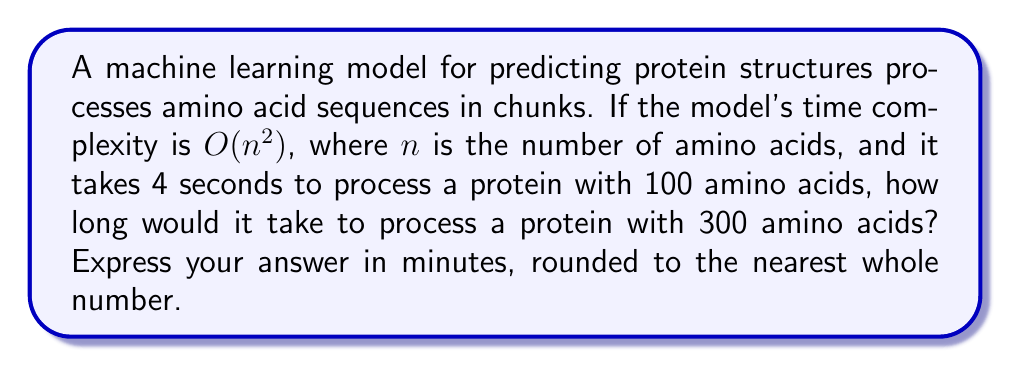Help me with this question. Let's approach this step-by-step:

1) The time complexity is $O(n^2)$, which means the processing time is proportional to the square of the input size.

2) We're given that for $n = 100$, the processing time $t = 4$ seconds.

3) Let's call the constant of proportionality $k$. So we can write:

   $t = kn^2$

4) For $n = 100$ and $t = 4$:

   $4 = k(100)^2$
   $4 = 10000k$
   $k = 4/10000 = 1/2500$

5) Now for $n = 300$, we can calculate the new time $t'$:

   $t' = (1/2500)(300)^2$
   $t' = (1/2500)(90000)$
   $t' = 36$ seconds

6) To convert to minutes:

   $36 \text{ seconds} = 36/60 \text{ minutes} = 0.6 \text{ minutes}$

7) Rounding to the nearest whole number:

   $0.6 \text{ minutes} \approx 1 \text{ minute}$

This problem illustrates how the quadratic time complexity of some machine learning algorithms can significantly increase processing time as the input size grows, which is crucial in computational biology where proteins can vary greatly in size.
Answer: 1 minute 